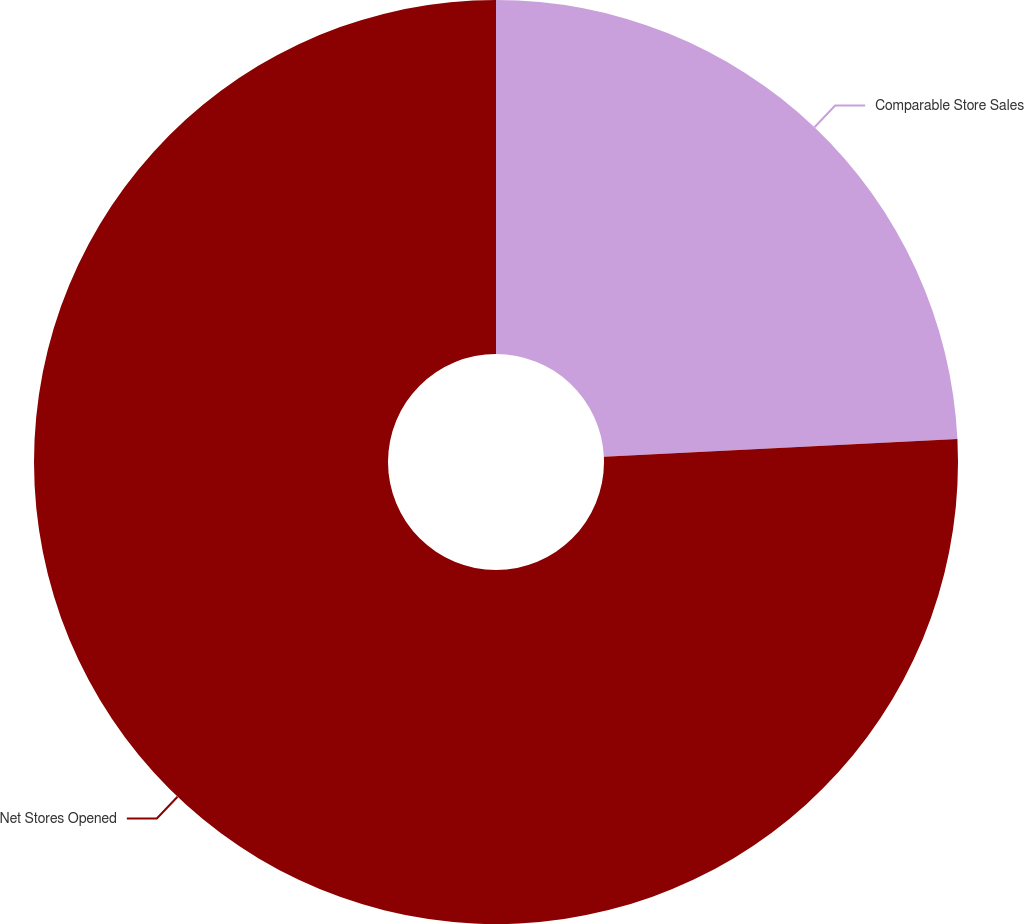Convert chart. <chart><loc_0><loc_0><loc_500><loc_500><pie_chart><fcel>Comparable Store Sales<fcel>Net Stores Opened<nl><fcel>24.21%<fcel>75.79%<nl></chart> 